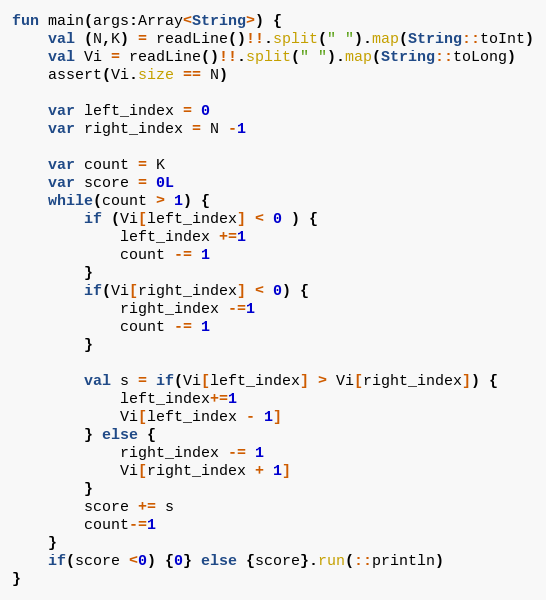Convert code to text. <code><loc_0><loc_0><loc_500><loc_500><_Kotlin_>fun main(args:Array<String>) {
    val (N,K) = readLine()!!.split(" ").map(String::toInt)
    val Vi = readLine()!!.split(" ").map(String::toLong)
    assert(Vi.size == N)

    var left_index = 0
    var right_index = N -1 

    var count = K 
    var score = 0L
    while(count > 1) {
        if (Vi[left_index] < 0 ) {
            left_index +=1 
            count -= 1
        }
        if(Vi[right_index] < 0) {
            right_index -=1
            count -= 1
        }

        val s = if(Vi[left_index] > Vi[right_index]) {
            left_index+=1
            Vi[left_index - 1]
        } else {
            right_index -= 1 
            Vi[right_index + 1]
        }
        score += s
        count-=1
    }
    if(score <0) {0} else {score}.run(::println)
}</code> 